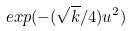<formula> <loc_0><loc_0><loc_500><loc_500>e x p ( - ( \sqrt { k } / 4 ) u ^ { 2 } )</formula> 